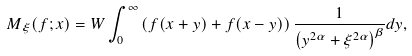<formula> <loc_0><loc_0><loc_500><loc_500>M _ { \xi } ( f ; x ) = W \int _ { 0 } ^ { \infty } \left ( f ( x + y ) + f ( x - y ) \right ) \frac { 1 } { \left ( y ^ { 2 \alpha } + \xi ^ { 2 \alpha } \right ) ^ { \beta } } d y ,</formula> 